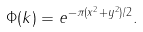Convert formula to latex. <formula><loc_0><loc_0><loc_500><loc_500>\Phi ( k ) = e ^ { - \pi ( x ^ { 2 } + y ^ { 2 } ) / 2 } .</formula> 